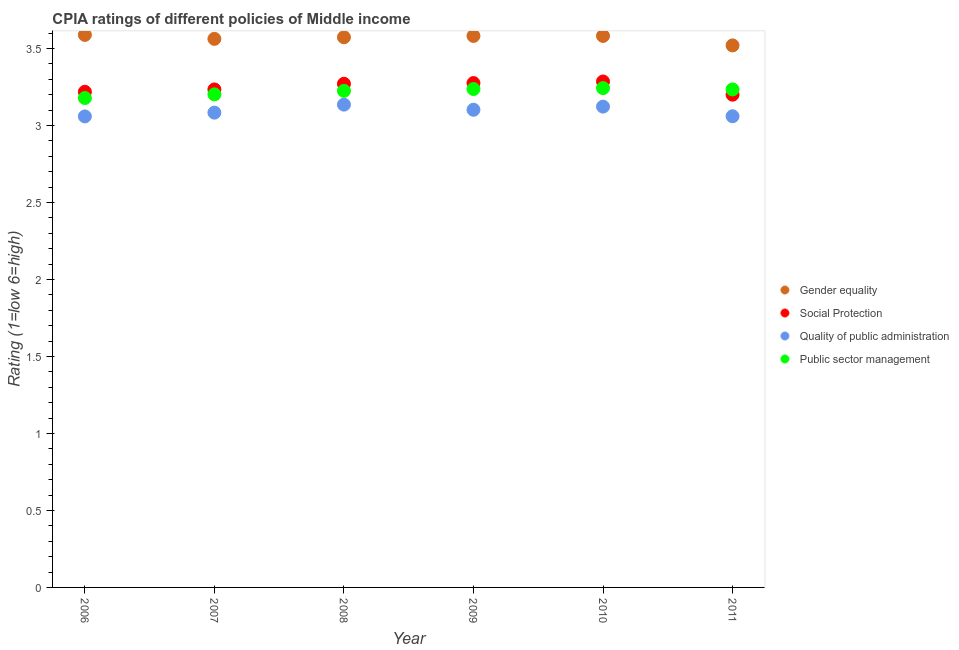How many different coloured dotlines are there?
Provide a succinct answer. 4. What is the cpia rating of quality of public administration in 2008?
Your answer should be very brief. 3.14. Across all years, what is the maximum cpia rating of social protection?
Your answer should be compact. 3.29. Across all years, what is the minimum cpia rating of public sector management?
Provide a short and direct response. 3.18. In which year was the cpia rating of public sector management maximum?
Make the answer very short. 2010. In which year was the cpia rating of public sector management minimum?
Provide a short and direct response. 2006. What is the total cpia rating of social protection in the graph?
Your answer should be very brief. 19.48. What is the difference between the cpia rating of gender equality in 2007 and that in 2011?
Offer a very short reply. 0.04. What is the difference between the cpia rating of quality of public administration in 2007 and the cpia rating of gender equality in 2009?
Your answer should be compact. -0.5. What is the average cpia rating of public sector management per year?
Make the answer very short. 3.22. In the year 2010, what is the difference between the cpia rating of social protection and cpia rating of public sector management?
Provide a succinct answer. 0.04. What is the ratio of the cpia rating of social protection in 2010 to that in 2011?
Give a very brief answer. 1.03. Is the cpia rating of gender equality in 2010 less than that in 2011?
Your answer should be very brief. No. What is the difference between the highest and the second highest cpia rating of quality of public administration?
Provide a short and direct response. 0.01. What is the difference between the highest and the lowest cpia rating of quality of public administration?
Ensure brevity in your answer.  0.08. In how many years, is the cpia rating of social protection greater than the average cpia rating of social protection taken over all years?
Your answer should be compact. 3. Is the sum of the cpia rating of gender equality in 2006 and 2007 greater than the maximum cpia rating of public sector management across all years?
Keep it short and to the point. Yes. Is it the case that in every year, the sum of the cpia rating of social protection and cpia rating of public sector management is greater than the sum of cpia rating of quality of public administration and cpia rating of gender equality?
Offer a terse response. Yes. Is it the case that in every year, the sum of the cpia rating of gender equality and cpia rating of social protection is greater than the cpia rating of quality of public administration?
Keep it short and to the point. Yes. Does the cpia rating of social protection monotonically increase over the years?
Ensure brevity in your answer.  No. How many years are there in the graph?
Your response must be concise. 6. What is the difference between two consecutive major ticks on the Y-axis?
Make the answer very short. 0.5. Are the values on the major ticks of Y-axis written in scientific E-notation?
Keep it short and to the point. No. Does the graph contain grids?
Give a very brief answer. No. How many legend labels are there?
Offer a very short reply. 4. What is the title of the graph?
Ensure brevity in your answer.  CPIA ratings of different policies of Middle income. Does "Primary schools" appear as one of the legend labels in the graph?
Provide a short and direct response. No. What is the label or title of the Y-axis?
Offer a very short reply. Rating (1=low 6=high). What is the Rating (1=low 6=high) in Gender equality in 2006?
Offer a very short reply. 3.59. What is the Rating (1=low 6=high) in Social Protection in 2006?
Ensure brevity in your answer.  3.22. What is the Rating (1=low 6=high) in Quality of public administration in 2006?
Offer a very short reply. 3.06. What is the Rating (1=low 6=high) of Public sector management in 2006?
Provide a short and direct response. 3.18. What is the Rating (1=low 6=high) in Gender equality in 2007?
Ensure brevity in your answer.  3.56. What is the Rating (1=low 6=high) in Social Protection in 2007?
Keep it short and to the point. 3.23. What is the Rating (1=low 6=high) of Quality of public administration in 2007?
Keep it short and to the point. 3.08. What is the Rating (1=low 6=high) of Public sector management in 2007?
Provide a succinct answer. 3.2. What is the Rating (1=low 6=high) of Gender equality in 2008?
Provide a short and direct response. 3.57. What is the Rating (1=low 6=high) in Social Protection in 2008?
Offer a very short reply. 3.27. What is the Rating (1=low 6=high) of Quality of public administration in 2008?
Offer a terse response. 3.14. What is the Rating (1=low 6=high) in Public sector management in 2008?
Provide a succinct answer. 3.23. What is the Rating (1=low 6=high) in Gender equality in 2009?
Your answer should be very brief. 3.58. What is the Rating (1=low 6=high) in Social Protection in 2009?
Offer a very short reply. 3.28. What is the Rating (1=low 6=high) in Quality of public administration in 2009?
Give a very brief answer. 3.1. What is the Rating (1=low 6=high) in Public sector management in 2009?
Provide a succinct answer. 3.24. What is the Rating (1=low 6=high) of Gender equality in 2010?
Your answer should be compact. 3.58. What is the Rating (1=low 6=high) in Social Protection in 2010?
Offer a terse response. 3.29. What is the Rating (1=low 6=high) of Quality of public administration in 2010?
Offer a very short reply. 3.12. What is the Rating (1=low 6=high) in Public sector management in 2010?
Provide a succinct answer. 3.24. What is the Rating (1=low 6=high) of Gender equality in 2011?
Give a very brief answer. 3.52. What is the Rating (1=low 6=high) in Quality of public administration in 2011?
Your response must be concise. 3.06. What is the Rating (1=low 6=high) of Public sector management in 2011?
Provide a short and direct response. 3.23. Across all years, what is the maximum Rating (1=low 6=high) of Gender equality?
Your response must be concise. 3.59. Across all years, what is the maximum Rating (1=low 6=high) of Social Protection?
Offer a very short reply. 3.29. Across all years, what is the maximum Rating (1=low 6=high) in Quality of public administration?
Give a very brief answer. 3.14. Across all years, what is the maximum Rating (1=low 6=high) of Public sector management?
Provide a succinct answer. 3.24. Across all years, what is the minimum Rating (1=low 6=high) in Gender equality?
Provide a short and direct response. 3.52. Across all years, what is the minimum Rating (1=low 6=high) in Social Protection?
Your answer should be very brief. 3.2. Across all years, what is the minimum Rating (1=low 6=high) of Quality of public administration?
Provide a succinct answer. 3.06. Across all years, what is the minimum Rating (1=low 6=high) in Public sector management?
Your response must be concise. 3.18. What is the total Rating (1=low 6=high) of Gender equality in the graph?
Offer a very short reply. 21.41. What is the total Rating (1=low 6=high) in Social Protection in the graph?
Your response must be concise. 19.48. What is the total Rating (1=low 6=high) of Quality of public administration in the graph?
Offer a very short reply. 18.56. What is the total Rating (1=low 6=high) in Public sector management in the graph?
Give a very brief answer. 19.32. What is the difference between the Rating (1=low 6=high) in Gender equality in 2006 and that in 2007?
Provide a succinct answer. 0.03. What is the difference between the Rating (1=low 6=high) in Social Protection in 2006 and that in 2007?
Offer a terse response. -0.02. What is the difference between the Rating (1=low 6=high) in Quality of public administration in 2006 and that in 2007?
Your answer should be compact. -0.02. What is the difference between the Rating (1=low 6=high) in Public sector management in 2006 and that in 2007?
Ensure brevity in your answer.  -0.02. What is the difference between the Rating (1=low 6=high) in Gender equality in 2006 and that in 2008?
Your answer should be compact. 0.02. What is the difference between the Rating (1=low 6=high) in Social Protection in 2006 and that in 2008?
Provide a succinct answer. -0.05. What is the difference between the Rating (1=low 6=high) of Quality of public administration in 2006 and that in 2008?
Keep it short and to the point. -0.08. What is the difference between the Rating (1=low 6=high) of Public sector management in 2006 and that in 2008?
Make the answer very short. -0.05. What is the difference between the Rating (1=low 6=high) of Gender equality in 2006 and that in 2009?
Your answer should be very brief. 0.01. What is the difference between the Rating (1=low 6=high) of Social Protection in 2006 and that in 2009?
Offer a very short reply. -0.06. What is the difference between the Rating (1=low 6=high) of Quality of public administration in 2006 and that in 2009?
Provide a short and direct response. -0.04. What is the difference between the Rating (1=low 6=high) in Public sector management in 2006 and that in 2009?
Your response must be concise. -0.06. What is the difference between the Rating (1=low 6=high) in Gender equality in 2006 and that in 2010?
Ensure brevity in your answer.  0.01. What is the difference between the Rating (1=low 6=high) in Social Protection in 2006 and that in 2010?
Offer a terse response. -0.07. What is the difference between the Rating (1=low 6=high) in Quality of public administration in 2006 and that in 2010?
Provide a short and direct response. -0.06. What is the difference between the Rating (1=low 6=high) in Public sector management in 2006 and that in 2010?
Offer a very short reply. -0.06. What is the difference between the Rating (1=low 6=high) in Gender equality in 2006 and that in 2011?
Your response must be concise. 0.07. What is the difference between the Rating (1=low 6=high) of Social Protection in 2006 and that in 2011?
Keep it short and to the point. 0.02. What is the difference between the Rating (1=low 6=high) in Quality of public administration in 2006 and that in 2011?
Give a very brief answer. -0. What is the difference between the Rating (1=low 6=high) in Public sector management in 2006 and that in 2011?
Your answer should be very brief. -0.06. What is the difference between the Rating (1=low 6=high) of Gender equality in 2007 and that in 2008?
Your answer should be compact. -0.01. What is the difference between the Rating (1=low 6=high) of Social Protection in 2007 and that in 2008?
Keep it short and to the point. -0.04. What is the difference between the Rating (1=low 6=high) in Quality of public administration in 2007 and that in 2008?
Your response must be concise. -0.05. What is the difference between the Rating (1=low 6=high) in Public sector management in 2007 and that in 2008?
Give a very brief answer. -0.02. What is the difference between the Rating (1=low 6=high) of Gender equality in 2007 and that in 2009?
Make the answer very short. -0.02. What is the difference between the Rating (1=low 6=high) of Social Protection in 2007 and that in 2009?
Your response must be concise. -0.04. What is the difference between the Rating (1=low 6=high) in Quality of public administration in 2007 and that in 2009?
Keep it short and to the point. -0.02. What is the difference between the Rating (1=low 6=high) in Public sector management in 2007 and that in 2009?
Offer a terse response. -0.03. What is the difference between the Rating (1=low 6=high) of Gender equality in 2007 and that in 2010?
Offer a very short reply. -0.02. What is the difference between the Rating (1=low 6=high) of Social Protection in 2007 and that in 2010?
Provide a short and direct response. -0.05. What is the difference between the Rating (1=low 6=high) of Quality of public administration in 2007 and that in 2010?
Provide a succinct answer. -0.04. What is the difference between the Rating (1=low 6=high) in Public sector management in 2007 and that in 2010?
Your answer should be compact. -0.04. What is the difference between the Rating (1=low 6=high) in Gender equality in 2007 and that in 2011?
Offer a terse response. 0.04. What is the difference between the Rating (1=low 6=high) of Social Protection in 2007 and that in 2011?
Your answer should be very brief. 0.03. What is the difference between the Rating (1=low 6=high) in Quality of public administration in 2007 and that in 2011?
Ensure brevity in your answer.  0.02. What is the difference between the Rating (1=low 6=high) in Public sector management in 2007 and that in 2011?
Give a very brief answer. -0.03. What is the difference between the Rating (1=low 6=high) of Gender equality in 2008 and that in 2009?
Keep it short and to the point. -0.01. What is the difference between the Rating (1=low 6=high) of Social Protection in 2008 and that in 2009?
Your answer should be compact. -0. What is the difference between the Rating (1=low 6=high) of Quality of public administration in 2008 and that in 2009?
Ensure brevity in your answer.  0.03. What is the difference between the Rating (1=low 6=high) of Public sector management in 2008 and that in 2009?
Your response must be concise. -0.01. What is the difference between the Rating (1=low 6=high) of Gender equality in 2008 and that in 2010?
Offer a very short reply. -0.01. What is the difference between the Rating (1=low 6=high) in Social Protection in 2008 and that in 2010?
Keep it short and to the point. -0.01. What is the difference between the Rating (1=low 6=high) in Quality of public administration in 2008 and that in 2010?
Give a very brief answer. 0.01. What is the difference between the Rating (1=low 6=high) of Public sector management in 2008 and that in 2010?
Your answer should be compact. -0.02. What is the difference between the Rating (1=low 6=high) in Gender equality in 2008 and that in 2011?
Offer a terse response. 0.05. What is the difference between the Rating (1=low 6=high) in Social Protection in 2008 and that in 2011?
Your answer should be compact. 0.07. What is the difference between the Rating (1=low 6=high) in Quality of public administration in 2008 and that in 2011?
Offer a terse response. 0.08. What is the difference between the Rating (1=low 6=high) in Public sector management in 2008 and that in 2011?
Your answer should be compact. -0.01. What is the difference between the Rating (1=low 6=high) in Social Protection in 2009 and that in 2010?
Your answer should be very brief. -0.01. What is the difference between the Rating (1=low 6=high) in Quality of public administration in 2009 and that in 2010?
Your response must be concise. -0.02. What is the difference between the Rating (1=low 6=high) in Public sector management in 2009 and that in 2010?
Offer a terse response. -0.01. What is the difference between the Rating (1=low 6=high) in Gender equality in 2009 and that in 2011?
Offer a very short reply. 0.06. What is the difference between the Rating (1=low 6=high) of Social Protection in 2009 and that in 2011?
Your response must be concise. 0.08. What is the difference between the Rating (1=low 6=high) in Quality of public administration in 2009 and that in 2011?
Your answer should be compact. 0.04. What is the difference between the Rating (1=low 6=high) of Public sector management in 2009 and that in 2011?
Provide a succinct answer. 0. What is the difference between the Rating (1=low 6=high) in Gender equality in 2010 and that in 2011?
Provide a short and direct response. 0.06. What is the difference between the Rating (1=low 6=high) of Social Protection in 2010 and that in 2011?
Your answer should be compact. 0.09. What is the difference between the Rating (1=low 6=high) in Quality of public administration in 2010 and that in 2011?
Provide a short and direct response. 0.06. What is the difference between the Rating (1=low 6=high) in Public sector management in 2010 and that in 2011?
Ensure brevity in your answer.  0.01. What is the difference between the Rating (1=low 6=high) of Gender equality in 2006 and the Rating (1=low 6=high) of Social Protection in 2007?
Offer a terse response. 0.35. What is the difference between the Rating (1=low 6=high) in Gender equality in 2006 and the Rating (1=low 6=high) in Quality of public administration in 2007?
Give a very brief answer. 0.5. What is the difference between the Rating (1=low 6=high) of Gender equality in 2006 and the Rating (1=low 6=high) of Public sector management in 2007?
Your response must be concise. 0.39. What is the difference between the Rating (1=low 6=high) of Social Protection in 2006 and the Rating (1=low 6=high) of Quality of public administration in 2007?
Make the answer very short. 0.14. What is the difference between the Rating (1=low 6=high) of Social Protection in 2006 and the Rating (1=low 6=high) of Public sector management in 2007?
Ensure brevity in your answer.  0.02. What is the difference between the Rating (1=low 6=high) of Quality of public administration in 2006 and the Rating (1=low 6=high) of Public sector management in 2007?
Your answer should be very brief. -0.14. What is the difference between the Rating (1=low 6=high) of Gender equality in 2006 and the Rating (1=low 6=high) of Social Protection in 2008?
Provide a succinct answer. 0.32. What is the difference between the Rating (1=low 6=high) of Gender equality in 2006 and the Rating (1=low 6=high) of Quality of public administration in 2008?
Offer a very short reply. 0.45. What is the difference between the Rating (1=low 6=high) of Gender equality in 2006 and the Rating (1=low 6=high) of Public sector management in 2008?
Your answer should be very brief. 0.36. What is the difference between the Rating (1=low 6=high) of Social Protection in 2006 and the Rating (1=low 6=high) of Quality of public administration in 2008?
Keep it short and to the point. 0.08. What is the difference between the Rating (1=low 6=high) of Social Protection in 2006 and the Rating (1=low 6=high) of Public sector management in 2008?
Your answer should be very brief. -0.01. What is the difference between the Rating (1=low 6=high) in Quality of public administration in 2006 and the Rating (1=low 6=high) in Public sector management in 2008?
Make the answer very short. -0.17. What is the difference between the Rating (1=low 6=high) of Gender equality in 2006 and the Rating (1=low 6=high) of Social Protection in 2009?
Make the answer very short. 0.31. What is the difference between the Rating (1=low 6=high) in Gender equality in 2006 and the Rating (1=low 6=high) in Quality of public administration in 2009?
Your answer should be compact. 0.49. What is the difference between the Rating (1=low 6=high) of Gender equality in 2006 and the Rating (1=low 6=high) of Public sector management in 2009?
Your answer should be compact. 0.35. What is the difference between the Rating (1=low 6=high) of Social Protection in 2006 and the Rating (1=low 6=high) of Quality of public administration in 2009?
Provide a short and direct response. 0.12. What is the difference between the Rating (1=low 6=high) in Social Protection in 2006 and the Rating (1=low 6=high) in Public sector management in 2009?
Give a very brief answer. -0.02. What is the difference between the Rating (1=low 6=high) of Quality of public administration in 2006 and the Rating (1=low 6=high) of Public sector management in 2009?
Give a very brief answer. -0.18. What is the difference between the Rating (1=low 6=high) of Gender equality in 2006 and the Rating (1=low 6=high) of Social Protection in 2010?
Keep it short and to the point. 0.3. What is the difference between the Rating (1=low 6=high) of Gender equality in 2006 and the Rating (1=low 6=high) of Quality of public administration in 2010?
Your answer should be compact. 0.47. What is the difference between the Rating (1=low 6=high) of Gender equality in 2006 and the Rating (1=low 6=high) of Public sector management in 2010?
Your answer should be compact. 0.35. What is the difference between the Rating (1=low 6=high) of Social Protection in 2006 and the Rating (1=low 6=high) of Quality of public administration in 2010?
Provide a succinct answer. 0.1. What is the difference between the Rating (1=low 6=high) in Social Protection in 2006 and the Rating (1=low 6=high) in Public sector management in 2010?
Your response must be concise. -0.02. What is the difference between the Rating (1=low 6=high) in Quality of public administration in 2006 and the Rating (1=low 6=high) in Public sector management in 2010?
Keep it short and to the point. -0.18. What is the difference between the Rating (1=low 6=high) in Gender equality in 2006 and the Rating (1=low 6=high) in Social Protection in 2011?
Your answer should be very brief. 0.39. What is the difference between the Rating (1=low 6=high) in Gender equality in 2006 and the Rating (1=low 6=high) in Quality of public administration in 2011?
Your answer should be compact. 0.53. What is the difference between the Rating (1=low 6=high) in Gender equality in 2006 and the Rating (1=low 6=high) in Public sector management in 2011?
Offer a very short reply. 0.35. What is the difference between the Rating (1=low 6=high) in Social Protection in 2006 and the Rating (1=low 6=high) in Quality of public administration in 2011?
Your response must be concise. 0.16. What is the difference between the Rating (1=low 6=high) of Social Protection in 2006 and the Rating (1=low 6=high) of Public sector management in 2011?
Offer a terse response. -0.02. What is the difference between the Rating (1=low 6=high) of Quality of public administration in 2006 and the Rating (1=low 6=high) of Public sector management in 2011?
Give a very brief answer. -0.18. What is the difference between the Rating (1=low 6=high) in Gender equality in 2007 and the Rating (1=low 6=high) in Social Protection in 2008?
Your response must be concise. 0.29. What is the difference between the Rating (1=low 6=high) of Gender equality in 2007 and the Rating (1=low 6=high) of Quality of public administration in 2008?
Provide a succinct answer. 0.43. What is the difference between the Rating (1=low 6=high) in Gender equality in 2007 and the Rating (1=low 6=high) in Public sector management in 2008?
Make the answer very short. 0.34. What is the difference between the Rating (1=low 6=high) in Social Protection in 2007 and the Rating (1=low 6=high) in Quality of public administration in 2008?
Give a very brief answer. 0.1. What is the difference between the Rating (1=low 6=high) in Social Protection in 2007 and the Rating (1=low 6=high) in Public sector management in 2008?
Your answer should be very brief. 0.01. What is the difference between the Rating (1=low 6=high) in Quality of public administration in 2007 and the Rating (1=low 6=high) in Public sector management in 2008?
Offer a terse response. -0.14. What is the difference between the Rating (1=low 6=high) of Gender equality in 2007 and the Rating (1=low 6=high) of Social Protection in 2009?
Provide a succinct answer. 0.29. What is the difference between the Rating (1=low 6=high) in Gender equality in 2007 and the Rating (1=low 6=high) in Quality of public administration in 2009?
Your response must be concise. 0.46. What is the difference between the Rating (1=low 6=high) in Gender equality in 2007 and the Rating (1=low 6=high) in Public sector management in 2009?
Keep it short and to the point. 0.33. What is the difference between the Rating (1=low 6=high) of Social Protection in 2007 and the Rating (1=low 6=high) of Quality of public administration in 2009?
Keep it short and to the point. 0.13. What is the difference between the Rating (1=low 6=high) of Social Protection in 2007 and the Rating (1=low 6=high) of Public sector management in 2009?
Your answer should be compact. -0. What is the difference between the Rating (1=low 6=high) in Quality of public administration in 2007 and the Rating (1=low 6=high) in Public sector management in 2009?
Give a very brief answer. -0.15. What is the difference between the Rating (1=low 6=high) of Gender equality in 2007 and the Rating (1=low 6=high) of Social Protection in 2010?
Provide a short and direct response. 0.28. What is the difference between the Rating (1=low 6=high) in Gender equality in 2007 and the Rating (1=low 6=high) in Quality of public administration in 2010?
Give a very brief answer. 0.44. What is the difference between the Rating (1=low 6=high) in Gender equality in 2007 and the Rating (1=low 6=high) in Public sector management in 2010?
Keep it short and to the point. 0.32. What is the difference between the Rating (1=low 6=high) of Social Protection in 2007 and the Rating (1=low 6=high) of Quality of public administration in 2010?
Your answer should be compact. 0.11. What is the difference between the Rating (1=low 6=high) of Social Protection in 2007 and the Rating (1=low 6=high) of Public sector management in 2010?
Offer a terse response. -0.01. What is the difference between the Rating (1=low 6=high) of Quality of public administration in 2007 and the Rating (1=low 6=high) of Public sector management in 2010?
Ensure brevity in your answer.  -0.16. What is the difference between the Rating (1=low 6=high) of Gender equality in 2007 and the Rating (1=low 6=high) of Social Protection in 2011?
Provide a succinct answer. 0.36. What is the difference between the Rating (1=low 6=high) in Gender equality in 2007 and the Rating (1=low 6=high) in Quality of public administration in 2011?
Provide a short and direct response. 0.5. What is the difference between the Rating (1=low 6=high) in Gender equality in 2007 and the Rating (1=low 6=high) in Public sector management in 2011?
Provide a short and direct response. 0.33. What is the difference between the Rating (1=low 6=high) of Social Protection in 2007 and the Rating (1=low 6=high) of Quality of public administration in 2011?
Give a very brief answer. 0.17. What is the difference between the Rating (1=low 6=high) in Quality of public administration in 2007 and the Rating (1=low 6=high) in Public sector management in 2011?
Your response must be concise. -0.15. What is the difference between the Rating (1=low 6=high) in Gender equality in 2008 and the Rating (1=low 6=high) in Social Protection in 2009?
Ensure brevity in your answer.  0.3. What is the difference between the Rating (1=low 6=high) of Gender equality in 2008 and the Rating (1=low 6=high) of Quality of public administration in 2009?
Your response must be concise. 0.47. What is the difference between the Rating (1=low 6=high) in Gender equality in 2008 and the Rating (1=low 6=high) in Public sector management in 2009?
Your response must be concise. 0.34. What is the difference between the Rating (1=low 6=high) in Social Protection in 2008 and the Rating (1=low 6=high) in Quality of public administration in 2009?
Ensure brevity in your answer.  0.17. What is the difference between the Rating (1=low 6=high) of Social Protection in 2008 and the Rating (1=low 6=high) of Public sector management in 2009?
Make the answer very short. 0.03. What is the difference between the Rating (1=low 6=high) in Quality of public administration in 2008 and the Rating (1=low 6=high) in Public sector management in 2009?
Your answer should be very brief. -0.1. What is the difference between the Rating (1=low 6=high) in Gender equality in 2008 and the Rating (1=low 6=high) in Social Protection in 2010?
Provide a short and direct response. 0.29. What is the difference between the Rating (1=low 6=high) of Gender equality in 2008 and the Rating (1=low 6=high) of Quality of public administration in 2010?
Keep it short and to the point. 0.45. What is the difference between the Rating (1=low 6=high) in Gender equality in 2008 and the Rating (1=low 6=high) in Public sector management in 2010?
Your response must be concise. 0.33. What is the difference between the Rating (1=low 6=high) of Social Protection in 2008 and the Rating (1=low 6=high) of Quality of public administration in 2010?
Provide a succinct answer. 0.15. What is the difference between the Rating (1=low 6=high) in Social Protection in 2008 and the Rating (1=low 6=high) in Public sector management in 2010?
Your response must be concise. 0.03. What is the difference between the Rating (1=low 6=high) in Quality of public administration in 2008 and the Rating (1=low 6=high) in Public sector management in 2010?
Give a very brief answer. -0.11. What is the difference between the Rating (1=low 6=high) in Gender equality in 2008 and the Rating (1=low 6=high) in Social Protection in 2011?
Keep it short and to the point. 0.37. What is the difference between the Rating (1=low 6=high) of Gender equality in 2008 and the Rating (1=low 6=high) of Quality of public administration in 2011?
Keep it short and to the point. 0.51. What is the difference between the Rating (1=low 6=high) in Gender equality in 2008 and the Rating (1=low 6=high) in Public sector management in 2011?
Your answer should be compact. 0.34. What is the difference between the Rating (1=low 6=high) of Social Protection in 2008 and the Rating (1=low 6=high) of Quality of public administration in 2011?
Offer a terse response. 0.21. What is the difference between the Rating (1=low 6=high) of Social Protection in 2008 and the Rating (1=low 6=high) of Public sector management in 2011?
Make the answer very short. 0.04. What is the difference between the Rating (1=low 6=high) of Quality of public administration in 2008 and the Rating (1=low 6=high) of Public sector management in 2011?
Give a very brief answer. -0.1. What is the difference between the Rating (1=low 6=high) of Gender equality in 2009 and the Rating (1=low 6=high) of Social Protection in 2010?
Your response must be concise. 0.3. What is the difference between the Rating (1=low 6=high) of Gender equality in 2009 and the Rating (1=low 6=high) of Quality of public administration in 2010?
Ensure brevity in your answer.  0.46. What is the difference between the Rating (1=low 6=high) of Gender equality in 2009 and the Rating (1=low 6=high) of Public sector management in 2010?
Make the answer very short. 0.34. What is the difference between the Rating (1=low 6=high) in Social Protection in 2009 and the Rating (1=low 6=high) in Quality of public administration in 2010?
Offer a terse response. 0.15. What is the difference between the Rating (1=low 6=high) of Social Protection in 2009 and the Rating (1=low 6=high) of Public sector management in 2010?
Your response must be concise. 0.03. What is the difference between the Rating (1=low 6=high) in Quality of public administration in 2009 and the Rating (1=low 6=high) in Public sector management in 2010?
Provide a short and direct response. -0.14. What is the difference between the Rating (1=low 6=high) of Gender equality in 2009 and the Rating (1=low 6=high) of Social Protection in 2011?
Keep it short and to the point. 0.38. What is the difference between the Rating (1=low 6=high) of Gender equality in 2009 and the Rating (1=low 6=high) of Quality of public administration in 2011?
Provide a short and direct response. 0.52. What is the difference between the Rating (1=low 6=high) of Gender equality in 2009 and the Rating (1=low 6=high) of Public sector management in 2011?
Provide a short and direct response. 0.35. What is the difference between the Rating (1=low 6=high) in Social Protection in 2009 and the Rating (1=low 6=high) in Quality of public administration in 2011?
Offer a terse response. 0.22. What is the difference between the Rating (1=low 6=high) of Social Protection in 2009 and the Rating (1=low 6=high) of Public sector management in 2011?
Ensure brevity in your answer.  0.04. What is the difference between the Rating (1=low 6=high) in Quality of public administration in 2009 and the Rating (1=low 6=high) in Public sector management in 2011?
Offer a terse response. -0.13. What is the difference between the Rating (1=low 6=high) of Gender equality in 2010 and the Rating (1=low 6=high) of Social Protection in 2011?
Make the answer very short. 0.38. What is the difference between the Rating (1=low 6=high) in Gender equality in 2010 and the Rating (1=low 6=high) in Quality of public administration in 2011?
Give a very brief answer. 0.52. What is the difference between the Rating (1=low 6=high) of Gender equality in 2010 and the Rating (1=low 6=high) of Public sector management in 2011?
Offer a terse response. 0.35. What is the difference between the Rating (1=low 6=high) of Social Protection in 2010 and the Rating (1=low 6=high) of Quality of public administration in 2011?
Offer a terse response. 0.23. What is the difference between the Rating (1=low 6=high) of Social Protection in 2010 and the Rating (1=low 6=high) of Public sector management in 2011?
Your answer should be compact. 0.05. What is the difference between the Rating (1=low 6=high) of Quality of public administration in 2010 and the Rating (1=low 6=high) of Public sector management in 2011?
Offer a very short reply. -0.11. What is the average Rating (1=low 6=high) of Gender equality per year?
Your response must be concise. 3.57. What is the average Rating (1=low 6=high) of Social Protection per year?
Your answer should be very brief. 3.25. What is the average Rating (1=low 6=high) of Quality of public administration per year?
Make the answer very short. 3.09. What is the average Rating (1=low 6=high) of Public sector management per year?
Offer a terse response. 3.22. In the year 2006, what is the difference between the Rating (1=low 6=high) in Gender equality and Rating (1=low 6=high) in Social Protection?
Offer a terse response. 0.37. In the year 2006, what is the difference between the Rating (1=low 6=high) in Gender equality and Rating (1=low 6=high) in Quality of public administration?
Offer a terse response. 0.53. In the year 2006, what is the difference between the Rating (1=low 6=high) of Gender equality and Rating (1=low 6=high) of Public sector management?
Keep it short and to the point. 0.41. In the year 2006, what is the difference between the Rating (1=low 6=high) of Social Protection and Rating (1=low 6=high) of Quality of public administration?
Ensure brevity in your answer.  0.16. In the year 2006, what is the difference between the Rating (1=low 6=high) of Social Protection and Rating (1=low 6=high) of Public sector management?
Your answer should be compact. 0.04. In the year 2006, what is the difference between the Rating (1=low 6=high) of Quality of public administration and Rating (1=low 6=high) of Public sector management?
Make the answer very short. -0.12. In the year 2007, what is the difference between the Rating (1=low 6=high) of Gender equality and Rating (1=low 6=high) of Social Protection?
Give a very brief answer. 0.33. In the year 2007, what is the difference between the Rating (1=low 6=high) of Gender equality and Rating (1=low 6=high) of Quality of public administration?
Make the answer very short. 0.48. In the year 2007, what is the difference between the Rating (1=low 6=high) in Gender equality and Rating (1=low 6=high) in Public sector management?
Your response must be concise. 0.36. In the year 2007, what is the difference between the Rating (1=low 6=high) of Social Protection and Rating (1=low 6=high) of Quality of public administration?
Offer a terse response. 0.15. In the year 2007, what is the difference between the Rating (1=low 6=high) in Social Protection and Rating (1=low 6=high) in Public sector management?
Offer a terse response. 0.03. In the year 2007, what is the difference between the Rating (1=low 6=high) in Quality of public administration and Rating (1=low 6=high) in Public sector management?
Provide a succinct answer. -0.12. In the year 2008, what is the difference between the Rating (1=low 6=high) of Gender equality and Rating (1=low 6=high) of Social Protection?
Provide a short and direct response. 0.3. In the year 2008, what is the difference between the Rating (1=low 6=high) in Gender equality and Rating (1=low 6=high) in Quality of public administration?
Your answer should be very brief. 0.44. In the year 2008, what is the difference between the Rating (1=low 6=high) of Gender equality and Rating (1=low 6=high) of Public sector management?
Your answer should be compact. 0.35. In the year 2008, what is the difference between the Rating (1=low 6=high) of Social Protection and Rating (1=low 6=high) of Quality of public administration?
Give a very brief answer. 0.14. In the year 2008, what is the difference between the Rating (1=low 6=high) in Social Protection and Rating (1=low 6=high) in Public sector management?
Offer a terse response. 0.05. In the year 2008, what is the difference between the Rating (1=low 6=high) in Quality of public administration and Rating (1=low 6=high) in Public sector management?
Provide a succinct answer. -0.09. In the year 2009, what is the difference between the Rating (1=low 6=high) of Gender equality and Rating (1=low 6=high) of Social Protection?
Ensure brevity in your answer.  0.31. In the year 2009, what is the difference between the Rating (1=low 6=high) of Gender equality and Rating (1=low 6=high) of Quality of public administration?
Provide a short and direct response. 0.48. In the year 2009, what is the difference between the Rating (1=low 6=high) of Gender equality and Rating (1=low 6=high) of Public sector management?
Provide a succinct answer. 0.34. In the year 2009, what is the difference between the Rating (1=low 6=high) of Social Protection and Rating (1=low 6=high) of Quality of public administration?
Give a very brief answer. 0.17. In the year 2009, what is the difference between the Rating (1=low 6=high) of Social Protection and Rating (1=low 6=high) of Public sector management?
Your response must be concise. 0.04. In the year 2009, what is the difference between the Rating (1=low 6=high) of Quality of public administration and Rating (1=low 6=high) of Public sector management?
Your answer should be compact. -0.13. In the year 2010, what is the difference between the Rating (1=low 6=high) in Gender equality and Rating (1=low 6=high) in Social Protection?
Make the answer very short. 0.3. In the year 2010, what is the difference between the Rating (1=low 6=high) of Gender equality and Rating (1=low 6=high) of Quality of public administration?
Offer a terse response. 0.46. In the year 2010, what is the difference between the Rating (1=low 6=high) of Gender equality and Rating (1=low 6=high) of Public sector management?
Your answer should be compact. 0.34. In the year 2010, what is the difference between the Rating (1=low 6=high) of Social Protection and Rating (1=low 6=high) of Quality of public administration?
Your answer should be very brief. 0.16. In the year 2010, what is the difference between the Rating (1=low 6=high) in Social Protection and Rating (1=low 6=high) in Public sector management?
Offer a very short reply. 0.04. In the year 2010, what is the difference between the Rating (1=low 6=high) in Quality of public administration and Rating (1=low 6=high) in Public sector management?
Your response must be concise. -0.12. In the year 2011, what is the difference between the Rating (1=low 6=high) in Gender equality and Rating (1=low 6=high) in Social Protection?
Ensure brevity in your answer.  0.32. In the year 2011, what is the difference between the Rating (1=low 6=high) of Gender equality and Rating (1=low 6=high) of Quality of public administration?
Offer a very short reply. 0.46. In the year 2011, what is the difference between the Rating (1=low 6=high) of Gender equality and Rating (1=low 6=high) of Public sector management?
Provide a short and direct response. 0.29. In the year 2011, what is the difference between the Rating (1=low 6=high) in Social Protection and Rating (1=low 6=high) in Quality of public administration?
Your answer should be very brief. 0.14. In the year 2011, what is the difference between the Rating (1=low 6=high) in Social Protection and Rating (1=low 6=high) in Public sector management?
Provide a succinct answer. -0.03. In the year 2011, what is the difference between the Rating (1=low 6=high) in Quality of public administration and Rating (1=low 6=high) in Public sector management?
Offer a very short reply. -0.17. What is the ratio of the Rating (1=low 6=high) of Gender equality in 2006 to that in 2007?
Provide a short and direct response. 1.01. What is the ratio of the Rating (1=low 6=high) of Gender equality in 2006 to that in 2008?
Your answer should be compact. 1. What is the ratio of the Rating (1=low 6=high) in Social Protection in 2006 to that in 2008?
Your answer should be very brief. 0.98. What is the ratio of the Rating (1=low 6=high) in Quality of public administration in 2006 to that in 2008?
Give a very brief answer. 0.98. What is the ratio of the Rating (1=low 6=high) in Public sector management in 2006 to that in 2008?
Ensure brevity in your answer.  0.99. What is the ratio of the Rating (1=low 6=high) of Gender equality in 2006 to that in 2009?
Your answer should be compact. 1. What is the ratio of the Rating (1=low 6=high) of Social Protection in 2006 to that in 2009?
Keep it short and to the point. 0.98. What is the ratio of the Rating (1=low 6=high) of Quality of public administration in 2006 to that in 2009?
Offer a very short reply. 0.99. What is the ratio of the Rating (1=low 6=high) of Public sector management in 2006 to that in 2009?
Offer a terse response. 0.98. What is the ratio of the Rating (1=low 6=high) of Social Protection in 2006 to that in 2010?
Your answer should be compact. 0.98. What is the ratio of the Rating (1=low 6=high) in Quality of public administration in 2006 to that in 2010?
Offer a very short reply. 0.98. What is the ratio of the Rating (1=low 6=high) in Public sector management in 2006 to that in 2010?
Keep it short and to the point. 0.98. What is the ratio of the Rating (1=low 6=high) of Gender equality in 2006 to that in 2011?
Provide a short and direct response. 1.02. What is the ratio of the Rating (1=low 6=high) of Social Protection in 2006 to that in 2011?
Make the answer very short. 1.01. What is the ratio of the Rating (1=low 6=high) in Quality of public administration in 2006 to that in 2011?
Your answer should be compact. 1. What is the ratio of the Rating (1=low 6=high) of Public sector management in 2006 to that in 2011?
Offer a very short reply. 0.98. What is the ratio of the Rating (1=low 6=high) of Social Protection in 2007 to that in 2008?
Your answer should be compact. 0.99. What is the ratio of the Rating (1=low 6=high) of Quality of public administration in 2007 to that in 2008?
Your response must be concise. 0.98. What is the ratio of the Rating (1=low 6=high) of Social Protection in 2007 to that in 2009?
Provide a short and direct response. 0.99. What is the ratio of the Rating (1=low 6=high) in Public sector management in 2007 to that in 2009?
Provide a succinct answer. 0.99. What is the ratio of the Rating (1=low 6=high) in Gender equality in 2007 to that in 2010?
Make the answer very short. 0.99. What is the ratio of the Rating (1=low 6=high) of Social Protection in 2007 to that in 2010?
Your response must be concise. 0.98. What is the ratio of the Rating (1=low 6=high) of Quality of public administration in 2007 to that in 2010?
Ensure brevity in your answer.  0.99. What is the ratio of the Rating (1=low 6=high) of Public sector management in 2007 to that in 2010?
Make the answer very short. 0.99. What is the ratio of the Rating (1=low 6=high) of Gender equality in 2007 to that in 2011?
Make the answer very short. 1.01. What is the ratio of the Rating (1=low 6=high) in Social Protection in 2007 to that in 2011?
Your response must be concise. 1.01. What is the ratio of the Rating (1=low 6=high) in Quality of public administration in 2007 to that in 2011?
Ensure brevity in your answer.  1.01. What is the ratio of the Rating (1=low 6=high) in Gender equality in 2008 to that in 2009?
Your answer should be compact. 1. What is the ratio of the Rating (1=low 6=high) of Social Protection in 2008 to that in 2009?
Make the answer very short. 1. What is the ratio of the Rating (1=low 6=high) in Quality of public administration in 2008 to that in 2009?
Your answer should be compact. 1.01. What is the ratio of the Rating (1=low 6=high) in Social Protection in 2008 to that in 2010?
Ensure brevity in your answer.  1. What is the ratio of the Rating (1=low 6=high) in Quality of public administration in 2008 to that in 2010?
Provide a short and direct response. 1. What is the ratio of the Rating (1=low 6=high) of Public sector management in 2008 to that in 2010?
Make the answer very short. 0.99. What is the ratio of the Rating (1=low 6=high) of Gender equality in 2008 to that in 2011?
Your response must be concise. 1.01. What is the ratio of the Rating (1=low 6=high) in Social Protection in 2008 to that in 2011?
Provide a succinct answer. 1.02. What is the ratio of the Rating (1=low 6=high) of Quality of public administration in 2008 to that in 2011?
Your answer should be very brief. 1.02. What is the ratio of the Rating (1=low 6=high) in Public sector management in 2008 to that in 2011?
Ensure brevity in your answer.  1. What is the ratio of the Rating (1=low 6=high) of Gender equality in 2009 to that in 2010?
Provide a succinct answer. 1. What is the ratio of the Rating (1=low 6=high) of Social Protection in 2009 to that in 2010?
Keep it short and to the point. 1. What is the ratio of the Rating (1=low 6=high) of Gender equality in 2009 to that in 2011?
Your response must be concise. 1.02. What is the ratio of the Rating (1=low 6=high) in Social Protection in 2009 to that in 2011?
Ensure brevity in your answer.  1.02. What is the ratio of the Rating (1=low 6=high) of Quality of public administration in 2009 to that in 2011?
Provide a short and direct response. 1.01. What is the ratio of the Rating (1=low 6=high) in Public sector management in 2009 to that in 2011?
Offer a very short reply. 1. What is the ratio of the Rating (1=low 6=high) in Gender equality in 2010 to that in 2011?
Your answer should be very brief. 1.02. What is the ratio of the Rating (1=low 6=high) in Social Protection in 2010 to that in 2011?
Your answer should be compact. 1.03. What is the ratio of the Rating (1=low 6=high) in Quality of public administration in 2010 to that in 2011?
Your response must be concise. 1.02. What is the difference between the highest and the second highest Rating (1=low 6=high) of Gender equality?
Give a very brief answer. 0.01. What is the difference between the highest and the second highest Rating (1=low 6=high) of Social Protection?
Offer a very short reply. 0.01. What is the difference between the highest and the second highest Rating (1=low 6=high) of Quality of public administration?
Offer a very short reply. 0.01. What is the difference between the highest and the second highest Rating (1=low 6=high) in Public sector management?
Make the answer very short. 0.01. What is the difference between the highest and the lowest Rating (1=low 6=high) of Gender equality?
Ensure brevity in your answer.  0.07. What is the difference between the highest and the lowest Rating (1=low 6=high) of Social Protection?
Provide a succinct answer. 0.09. What is the difference between the highest and the lowest Rating (1=low 6=high) in Quality of public administration?
Give a very brief answer. 0.08. What is the difference between the highest and the lowest Rating (1=low 6=high) in Public sector management?
Provide a succinct answer. 0.06. 